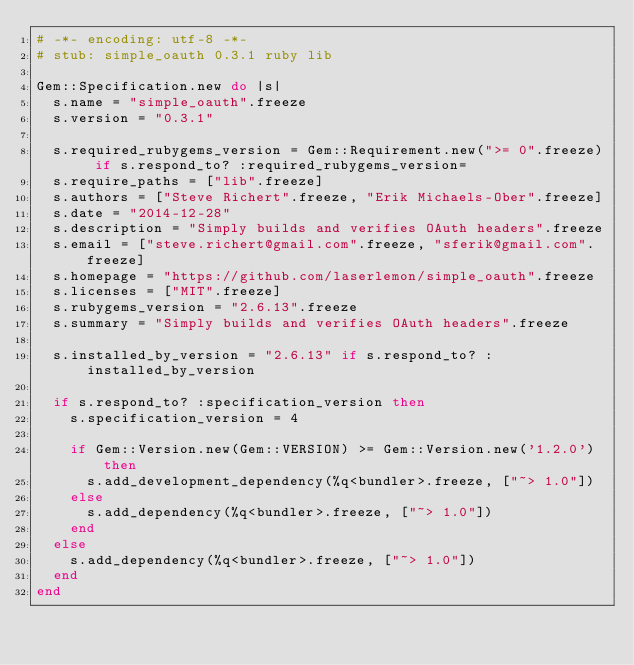Convert code to text. <code><loc_0><loc_0><loc_500><loc_500><_Ruby_># -*- encoding: utf-8 -*-
# stub: simple_oauth 0.3.1 ruby lib

Gem::Specification.new do |s|
  s.name = "simple_oauth".freeze
  s.version = "0.3.1"

  s.required_rubygems_version = Gem::Requirement.new(">= 0".freeze) if s.respond_to? :required_rubygems_version=
  s.require_paths = ["lib".freeze]
  s.authors = ["Steve Richert".freeze, "Erik Michaels-Ober".freeze]
  s.date = "2014-12-28"
  s.description = "Simply builds and verifies OAuth headers".freeze
  s.email = ["steve.richert@gmail.com".freeze, "sferik@gmail.com".freeze]
  s.homepage = "https://github.com/laserlemon/simple_oauth".freeze
  s.licenses = ["MIT".freeze]
  s.rubygems_version = "2.6.13".freeze
  s.summary = "Simply builds and verifies OAuth headers".freeze

  s.installed_by_version = "2.6.13" if s.respond_to? :installed_by_version

  if s.respond_to? :specification_version then
    s.specification_version = 4

    if Gem::Version.new(Gem::VERSION) >= Gem::Version.new('1.2.0') then
      s.add_development_dependency(%q<bundler>.freeze, ["~> 1.0"])
    else
      s.add_dependency(%q<bundler>.freeze, ["~> 1.0"])
    end
  else
    s.add_dependency(%q<bundler>.freeze, ["~> 1.0"])
  end
end
</code> 